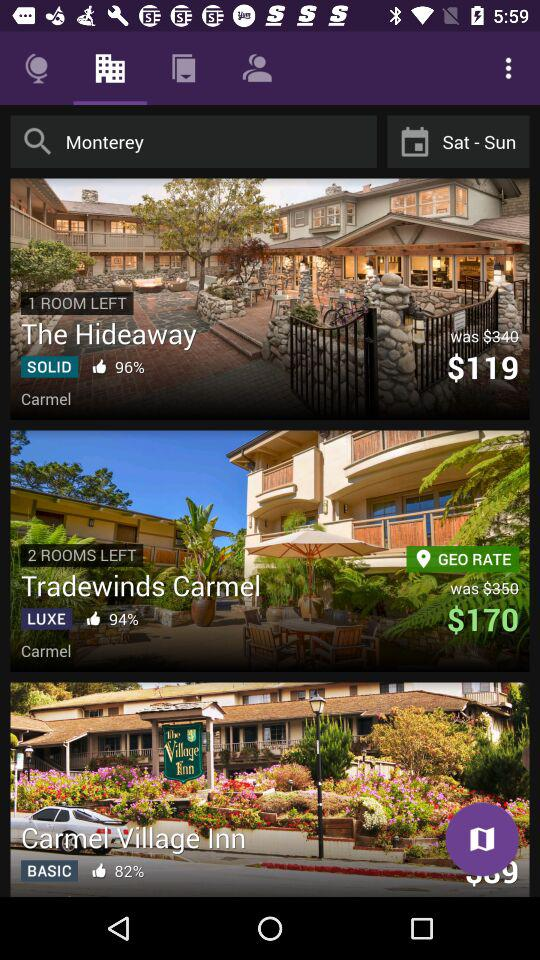What is the actual price of "The Hideaway"? The actual price of "The Hideaway" is $119. 